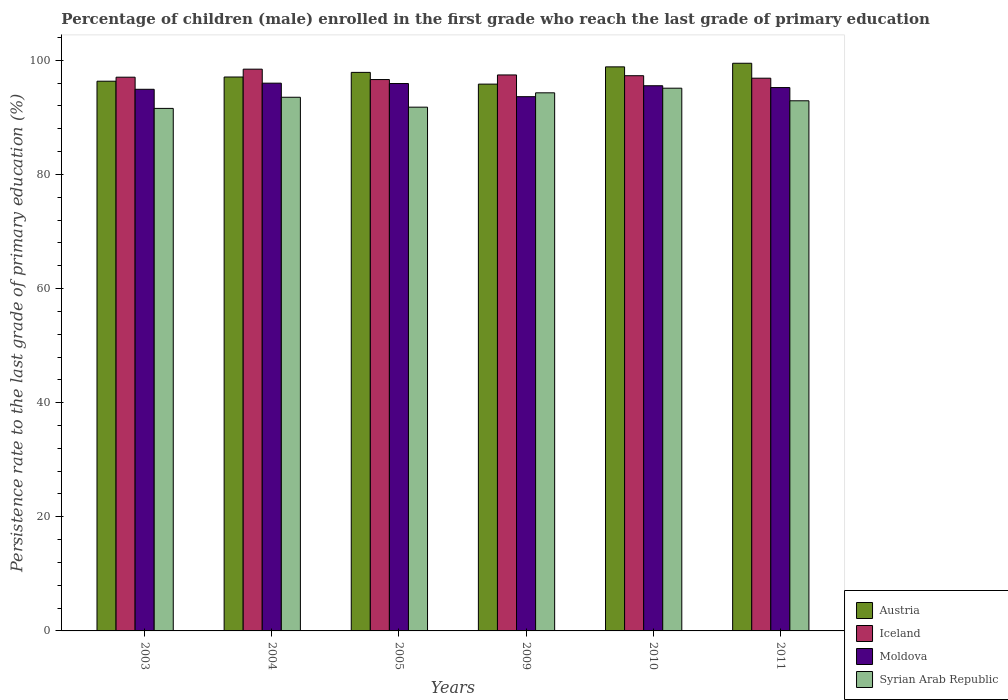How many bars are there on the 4th tick from the left?
Your answer should be compact. 4. How many bars are there on the 6th tick from the right?
Your answer should be compact. 4. In how many cases, is the number of bars for a given year not equal to the number of legend labels?
Provide a short and direct response. 0. What is the persistence rate of children in Iceland in 2010?
Offer a very short reply. 97.31. Across all years, what is the maximum persistence rate of children in Iceland?
Offer a terse response. 98.46. Across all years, what is the minimum persistence rate of children in Iceland?
Your response must be concise. 96.63. In which year was the persistence rate of children in Austria maximum?
Provide a succinct answer. 2011. What is the total persistence rate of children in Iceland in the graph?
Your answer should be very brief. 583.76. What is the difference between the persistence rate of children in Iceland in 2005 and that in 2011?
Provide a succinct answer. -0.24. What is the difference between the persistence rate of children in Moldova in 2011 and the persistence rate of children in Syrian Arab Republic in 2005?
Ensure brevity in your answer.  3.43. What is the average persistence rate of children in Austria per year?
Your answer should be very brief. 97.58. In the year 2003, what is the difference between the persistence rate of children in Moldova and persistence rate of children in Iceland?
Your answer should be very brief. -2.12. What is the ratio of the persistence rate of children in Austria in 2004 to that in 2010?
Provide a short and direct response. 0.98. What is the difference between the highest and the second highest persistence rate of children in Austria?
Offer a terse response. 0.63. What is the difference between the highest and the lowest persistence rate of children in Syrian Arab Republic?
Make the answer very short. 3.54. Is the sum of the persistence rate of children in Syrian Arab Republic in 2010 and 2011 greater than the maximum persistence rate of children in Moldova across all years?
Your answer should be compact. Yes. Is it the case that in every year, the sum of the persistence rate of children in Austria and persistence rate of children in Iceland is greater than the sum of persistence rate of children in Syrian Arab Republic and persistence rate of children in Moldova?
Make the answer very short. No. How many bars are there?
Provide a short and direct response. 24. How many years are there in the graph?
Offer a very short reply. 6. What is the difference between two consecutive major ticks on the Y-axis?
Your response must be concise. 20. How are the legend labels stacked?
Make the answer very short. Vertical. What is the title of the graph?
Your response must be concise. Percentage of children (male) enrolled in the first grade who reach the last grade of primary education. Does "South Africa" appear as one of the legend labels in the graph?
Ensure brevity in your answer.  No. What is the label or title of the X-axis?
Your answer should be very brief. Years. What is the label or title of the Y-axis?
Give a very brief answer. Persistence rate to the last grade of primary education (%). What is the Persistence rate to the last grade of primary education (%) of Austria in 2003?
Offer a very short reply. 96.34. What is the Persistence rate to the last grade of primary education (%) in Iceland in 2003?
Give a very brief answer. 97.05. What is the Persistence rate to the last grade of primary education (%) in Moldova in 2003?
Your answer should be very brief. 94.93. What is the Persistence rate to the last grade of primary education (%) in Syrian Arab Republic in 2003?
Your answer should be compact. 91.58. What is the Persistence rate to the last grade of primary education (%) in Austria in 2004?
Your answer should be compact. 97.08. What is the Persistence rate to the last grade of primary education (%) of Iceland in 2004?
Your response must be concise. 98.46. What is the Persistence rate to the last grade of primary education (%) of Moldova in 2004?
Give a very brief answer. 96. What is the Persistence rate to the last grade of primary education (%) in Syrian Arab Republic in 2004?
Ensure brevity in your answer.  93.53. What is the Persistence rate to the last grade of primary education (%) in Austria in 2005?
Ensure brevity in your answer.  97.89. What is the Persistence rate to the last grade of primary education (%) in Iceland in 2005?
Make the answer very short. 96.63. What is the Persistence rate to the last grade of primary education (%) of Moldova in 2005?
Give a very brief answer. 95.93. What is the Persistence rate to the last grade of primary education (%) of Syrian Arab Republic in 2005?
Keep it short and to the point. 91.8. What is the Persistence rate to the last grade of primary education (%) of Austria in 2009?
Offer a very short reply. 95.84. What is the Persistence rate to the last grade of primary education (%) in Iceland in 2009?
Give a very brief answer. 97.44. What is the Persistence rate to the last grade of primary education (%) in Moldova in 2009?
Make the answer very short. 93.63. What is the Persistence rate to the last grade of primary education (%) in Syrian Arab Republic in 2009?
Ensure brevity in your answer.  94.31. What is the Persistence rate to the last grade of primary education (%) in Austria in 2010?
Provide a succinct answer. 98.86. What is the Persistence rate to the last grade of primary education (%) in Iceland in 2010?
Make the answer very short. 97.31. What is the Persistence rate to the last grade of primary education (%) of Moldova in 2010?
Your answer should be compact. 95.55. What is the Persistence rate to the last grade of primary education (%) of Syrian Arab Republic in 2010?
Ensure brevity in your answer.  95.12. What is the Persistence rate to the last grade of primary education (%) in Austria in 2011?
Offer a very short reply. 99.49. What is the Persistence rate to the last grade of primary education (%) in Iceland in 2011?
Your answer should be very brief. 96.87. What is the Persistence rate to the last grade of primary education (%) of Moldova in 2011?
Give a very brief answer. 95.23. What is the Persistence rate to the last grade of primary education (%) of Syrian Arab Republic in 2011?
Offer a terse response. 92.91. Across all years, what is the maximum Persistence rate to the last grade of primary education (%) of Austria?
Give a very brief answer. 99.49. Across all years, what is the maximum Persistence rate to the last grade of primary education (%) of Iceland?
Your answer should be compact. 98.46. Across all years, what is the maximum Persistence rate to the last grade of primary education (%) of Moldova?
Offer a very short reply. 96. Across all years, what is the maximum Persistence rate to the last grade of primary education (%) in Syrian Arab Republic?
Your answer should be very brief. 95.12. Across all years, what is the minimum Persistence rate to the last grade of primary education (%) of Austria?
Make the answer very short. 95.84. Across all years, what is the minimum Persistence rate to the last grade of primary education (%) of Iceland?
Provide a short and direct response. 96.63. Across all years, what is the minimum Persistence rate to the last grade of primary education (%) in Moldova?
Ensure brevity in your answer.  93.63. Across all years, what is the minimum Persistence rate to the last grade of primary education (%) of Syrian Arab Republic?
Provide a short and direct response. 91.58. What is the total Persistence rate to the last grade of primary education (%) of Austria in the graph?
Your answer should be compact. 585.5. What is the total Persistence rate to the last grade of primary education (%) in Iceland in the graph?
Provide a succinct answer. 583.76. What is the total Persistence rate to the last grade of primary education (%) in Moldova in the graph?
Your response must be concise. 571.28. What is the total Persistence rate to the last grade of primary education (%) in Syrian Arab Republic in the graph?
Offer a terse response. 559.24. What is the difference between the Persistence rate to the last grade of primary education (%) of Austria in 2003 and that in 2004?
Provide a short and direct response. -0.74. What is the difference between the Persistence rate to the last grade of primary education (%) in Iceland in 2003 and that in 2004?
Offer a very short reply. -1.41. What is the difference between the Persistence rate to the last grade of primary education (%) in Moldova in 2003 and that in 2004?
Keep it short and to the point. -1.07. What is the difference between the Persistence rate to the last grade of primary education (%) of Syrian Arab Republic in 2003 and that in 2004?
Offer a very short reply. -1.95. What is the difference between the Persistence rate to the last grade of primary education (%) in Austria in 2003 and that in 2005?
Your answer should be compact. -1.55. What is the difference between the Persistence rate to the last grade of primary education (%) in Iceland in 2003 and that in 2005?
Keep it short and to the point. 0.41. What is the difference between the Persistence rate to the last grade of primary education (%) of Moldova in 2003 and that in 2005?
Offer a terse response. -1.01. What is the difference between the Persistence rate to the last grade of primary education (%) in Syrian Arab Republic in 2003 and that in 2005?
Your answer should be very brief. -0.22. What is the difference between the Persistence rate to the last grade of primary education (%) in Austria in 2003 and that in 2009?
Your answer should be very brief. 0.51. What is the difference between the Persistence rate to the last grade of primary education (%) of Iceland in 2003 and that in 2009?
Your response must be concise. -0.4. What is the difference between the Persistence rate to the last grade of primary education (%) of Moldova in 2003 and that in 2009?
Offer a terse response. 1.3. What is the difference between the Persistence rate to the last grade of primary education (%) in Syrian Arab Republic in 2003 and that in 2009?
Your response must be concise. -2.73. What is the difference between the Persistence rate to the last grade of primary education (%) of Austria in 2003 and that in 2010?
Your answer should be compact. -2.52. What is the difference between the Persistence rate to the last grade of primary education (%) in Iceland in 2003 and that in 2010?
Give a very brief answer. -0.26. What is the difference between the Persistence rate to the last grade of primary education (%) in Moldova in 2003 and that in 2010?
Offer a terse response. -0.62. What is the difference between the Persistence rate to the last grade of primary education (%) in Syrian Arab Republic in 2003 and that in 2010?
Keep it short and to the point. -3.54. What is the difference between the Persistence rate to the last grade of primary education (%) of Austria in 2003 and that in 2011?
Give a very brief answer. -3.15. What is the difference between the Persistence rate to the last grade of primary education (%) in Iceland in 2003 and that in 2011?
Provide a succinct answer. 0.17. What is the difference between the Persistence rate to the last grade of primary education (%) in Moldova in 2003 and that in 2011?
Give a very brief answer. -0.3. What is the difference between the Persistence rate to the last grade of primary education (%) in Syrian Arab Republic in 2003 and that in 2011?
Offer a terse response. -1.33. What is the difference between the Persistence rate to the last grade of primary education (%) in Austria in 2004 and that in 2005?
Ensure brevity in your answer.  -0.81. What is the difference between the Persistence rate to the last grade of primary education (%) of Iceland in 2004 and that in 2005?
Offer a terse response. 1.82. What is the difference between the Persistence rate to the last grade of primary education (%) in Moldova in 2004 and that in 2005?
Your response must be concise. 0.07. What is the difference between the Persistence rate to the last grade of primary education (%) in Syrian Arab Republic in 2004 and that in 2005?
Your answer should be compact. 1.74. What is the difference between the Persistence rate to the last grade of primary education (%) of Austria in 2004 and that in 2009?
Offer a terse response. 1.24. What is the difference between the Persistence rate to the last grade of primary education (%) in Iceland in 2004 and that in 2009?
Provide a short and direct response. 1.01. What is the difference between the Persistence rate to the last grade of primary education (%) of Moldova in 2004 and that in 2009?
Your answer should be compact. 2.37. What is the difference between the Persistence rate to the last grade of primary education (%) in Syrian Arab Republic in 2004 and that in 2009?
Your response must be concise. -0.78. What is the difference between the Persistence rate to the last grade of primary education (%) in Austria in 2004 and that in 2010?
Give a very brief answer. -1.78. What is the difference between the Persistence rate to the last grade of primary education (%) of Iceland in 2004 and that in 2010?
Keep it short and to the point. 1.15. What is the difference between the Persistence rate to the last grade of primary education (%) of Moldova in 2004 and that in 2010?
Your answer should be very brief. 0.45. What is the difference between the Persistence rate to the last grade of primary education (%) in Syrian Arab Republic in 2004 and that in 2010?
Offer a terse response. -1.59. What is the difference between the Persistence rate to the last grade of primary education (%) of Austria in 2004 and that in 2011?
Ensure brevity in your answer.  -2.41. What is the difference between the Persistence rate to the last grade of primary education (%) in Iceland in 2004 and that in 2011?
Provide a short and direct response. 1.58. What is the difference between the Persistence rate to the last grade of primary education (%) of Moldova in 2004 and that in 2011?
Your answer should be compact. 0.77. What is the difference between the Persistence rate to the last grade of primary education (%) in Syrian Arab Republic in 2004 and that in 2011?
Keep it short and to the point. 0.62. What is the difference between the Persistence rate to the last grade of primary education (%) in Austria in 2005 and that in 2009?
Ensure brevity in your answer.  2.06. What is the difference between the Persistence rate to the last grade of primary education (%) in Iceland in 2005 and that in 2009?
Your answer should be compact. -0.81. What is the difference between the Persistence rate to the last grade of primary education (%) of Moldova in 2005 and that in 2009?
Provide a short and direct response. 2.3. What is the difference between the Persistence rate to the last grade of primary education (%) in Syrian Arab Republic in 2005 and that in 2009?
Give a very brief answer. -2.51. What is the difference between the Persistence rate to the last grade of primary education (%) of Austria in 2005 and that in 2010?
Your response must be concise. -0.97. What is the difference between the Persistence rate to the last grade of primary education (%) of Iceland in 2005 and that in 2010?
Ensure brevity in your answer.  -0.67. What is the difference between the Persistence rate to the last grade of primary education (%) of Moldova in 2005 and that in 2010?
Your answer should be compact. 0.38. What is the difference between the Persistence rate to the last grade of primary education (%) of Syrian Arab Republic in 2005 and that in 2010?
Your answer should be compact. -3.32. What is the difference between the Persistence rate to the last grade of primary education (%) of Austria in 2005 and that in 2011?
Offer a terse response. -1.6. What is the difference between the Persistence rate to the last grade of primary education (%) of Iceland in 2005 and that in 2011?
Your answer should be compact. -0.24. What is the difference between the Persistence rate to the last grade of primary education (%) of Moldova in 2005 and that in 2011?
Offer a terse response. 0.71. What is the difference between the Persistence rate to the last grade of primary education (%) of Syrian Arab Republic in 2005 and that in 2011?
Offer a very short reply. -1.12. What is the difference between the Persistence rate to the last grade of primary education (%) in Austria in 2009 and that in 2010?
Offer a terse response. -3.02. What is the difference between the Persistence rate to the last grade of primary education (%) of Iceland in 2009 and that in 2010?
Give a very brief answer. 0.13. What is the difference between the Persistence rate to the last grade of primary education (%) of Moldova in 2009 and that in 2010?
Keep it short and to the point. -1.92. What is the difference between the Persistence rate to the last grade of primary education (%) in Syrian Arab Republic in 2009 and that in 2010?
Ensure brevity in your answer.  -0.81. What is the difference between the Persistence rate to the last grade of primary education (%) of Austria in 2009 and that in 2011?
Make the answer very short. -3.65. What is the difference between the Persistence rate to the last grade of primary education (%) of Iceland in 2009 and that in 2011?
Offer a terse response. 0.57. What is the difference between the Persistence rate to the last grade of primary education (%) in Moldova in 2009 and that in 2011?
Offer a terse response. -1.6. What is the difference between the Persistence rate to the last grade of primary education (%) in Syrian Arab Republic in 2009 and that in 2011?
Your answer should be compact. 1.4. What is the difference between the Persistence rate to the last grade of primary education (%) of Austria in 2010 and that in 2011?
Provide a succinct answer. -0.63. What is the difference between the Persistence rate to the last grade of primary education (%) of Iceland in 2010 and that in 2011?
Your answer should be compact. 0.43. What is the difference between the Persistence rate to the last grade of primary education (%) of Moldova in 2010 and that in 2011?
Keep it short and to the point. 0.32. What is the difference between the Persistence rate to the last grade of primary education (%) in Syrian Arab Republic in 2010 and that in 2011?
Offer a very short reply. 2.21. What is the difference between the Persistence rate to the last grade of primary education (%) of Austria in 2003 and the Persistence rate to the last grade of primary education (%) of Iceland in 2004?
Provide a short and direct response. -2.11. What is the difference between the Persistence rate to the last grade of primary education (%) in Austria in 2003 and the Persistence rate to the last grade of primary education (%) in Moldova in 2004?
Give a very brief answer. 0.34. What is the difference between the Persistence rate to the last grade of primary education (%) in Austria in 2003 and the Persistence rate to the last grade of primary education (%) in Syrian Arab Republic in 2004?
Your response must be concise. 2.81. What is the difference between the Persistence rate to the last grade of primary education (%) in Iceland in 2003 and the Persistence rate to the last grade of primary education (%) in Moldova in 2004?
Offer a very short reply. 1.04. What is the difference between the Persistence rate to the last grade of primary education (%) in Iceland in 2003 and the Persistence rate to the last grade of primary education (%) in Syrian Arab Republic in 2004?
Your answer should be compact. 3.52. What is the difference between the Persistence rate to the last grade of primary education (%) of Moldova in 2003 and the Persistence rate to the last grade of primary education (%) of Syrian Arab Republic in 2004?
Make the answer very short. 1.4. What is the difference between the Persistence rate to the last grade of primary education (%) of Austria in 2003 and the Persistence rate to the last grade of primary education (%) of Iceland in 2005?
Ensure brevity in your answer.  -0.29. What is the difference between the Persistence rate to the last grade of primary education (%) of Austria in 2003 and the Persistence rate to the last grade of primary education (%) of Moldova in 2005?
Your answer should be very brief. 0.41. What is the difference between the Persistence rate to the last grade of primary education (%) in Austria in 2003 and the Persistence rate to the last grade of primary education (%) in Syrian Arab Republic in 2005?
Ensure brevity in your answer.  4.55. What is the difference between the Persistence rate to the last grade of primary education (%) in Iceland in 2003 and the Persistence rate to the last grade of primary education (%) in Moldova in 2005?
Offer a terse response. 1.11. What is the difference between the Persistence rate to the last grade of primary education (%) in Iceland in 2003 and the Persistence rate to the last grade of primary education (%) in Syrian Arab Republic in 2005?
Offer a very short reply. 5.25. What is the difference between the Persistence rate to the last grade of primary education (%) of Moldova in 2003 and the Persistence rate to the last grade of primary education (%) of Syrian Arab Republic in 2005?
Provide a short and direct response. 3.13. What is the difference between the Persistence rate to the last grade of primary education (%) in Austria in 2003 and the Persistence rate to the last grade of primary education (%) in Iceland in 2009?
Your answer should be compact. -1.1. What is the difference between the Persistence rate to the last grade of primary education (%) in Austria in 2003 and the Persistence rate to the last grade of primary education (%) in Moldova in 2009?
Provide a succinct answer. 2.71. What is the difference between the Persistence rate to the last grade of primary education (%) in Austria in 2003 and the Persistence rate to the last grade of primary education (%) in Syrian Arab Republic in 2009?
Offer a terse response. 2.03. What is the difference between the Persistence rate to the last grade of primary education (%) of Iceland in 2003 and the Persistence rate to the last grade of primary education (%) of Moldova in 2009?
Make the answer very short. 3.41. What is the difference between the Persistence rate to the last grade of primary education (%) of Iceland in 2003 and the Persistence rate to the last grade of primary education (%) of Syrian Arab Republic in 2009?
Your response must be concise. 2.74. What is the difference between the Persistence rate to the last grade of primary education (%) in Moldova in 2003 and the Persistence rate to the last grade of primary education (%) in Syrian Arab Republic in 2009?
Your response must be concise. 0.62. What is the difference between the Persistence rate to the last grade of primary education (%) in Austria in 2003 and the Persistence rate to the last grade of primary education (%) in Iceland in 2010?
Ensure brevity in your answer.  -0.97. What is the difference between the Persistence rate to the last grade of primary education (%) of Austria in 2003 and the Persistence rate to the last grade of primary education (%) of Moldova in 2010?
Give a very brief answer. 0.79. What is the difference between the Persistence rate to the last grade of primary education (%) of Austria in 2003 and the Persistence rate to the last grade of primary education (%) of Syrian Arab Republic in 2010?
Your answer should be compact. 1.22. What is the difference between the Persistence rate to the last grade of primary education (%) of Iceland in 2003 and the Persistence rate to the last grade of primary education (%) of Moldova in 2010?
Give a very brief answer. 1.5. What is the difference between the Persistence rate to the last grade of primary education (%) of Iceland in 2003 and the Persistence rate to the last grade of primary education (%) of Syrian Arab Republic in 2010?
Keep it short and to the point. 1.93. What is the difference between the Persistence rate to the last grade of primary education (%) of Moldova in 2003 and the Persistence rate to the last grade of primary education (%) of Syrian Arab Republic in 2010?
Your answer should be compact. -0.19. What is the difference between the Persistence rate to the last grade of primary education (%) in Austria in 2003 and the Persistence rate to the last grade of primary education (%) in Iceland in 2011?
Your answer should be very brief. -0.53. What is the difference between the Persistence rate to the last grade of primary education (%) of Austria in 2003 and the Persistence rate to the last grade of primary education (%) of Moldova in 2011?
Provide a short and direct response. 1.11. What is the difference between the Persistence rate to the last grade of primary education (%) of Austria in 2003 and the Persistence rate to the last grade of primary education (%) of Syrian Arab Republic in 2011?
Ensure brevity in your answer.  3.43. What is the difference between the Persistence rate to the last grade of primary education (%) of Iceland in 2003 and the Persistence rate to the last grade of primary education (%) of Moldova in 2011?
Ensure brevity in your answer.  1.82. What is the difference between the Persistence rate to the last grade of primary education (%) of Iceland in 2003 and the Persistence rate to the last grade of primary education (%) of Syrian Arab Republic in 2011?
Make the answer very short. 4.13. What is the difference between the Persistence rate to the last grade of primary education (%) in Moldova in 2003 and the Persistence rate to the last grade of primary education (%) in Syrian Arab Republic in 2011?
Make the answer very short. 2.02. What is the difference between the Persistence rate to the last grade of primary education (%) of Austria in 2004 and the Persistence rate to the last grade of primary education (%) of Iceland in 2005?
Offer a terse response. 0.45. What is the difference between the Persistence rate to the last grade of primary education (%) in Austria in 2004 and the Persistence rate to the last grade of primary education (%) in Moldova in 2005?
Keep it short and to the point. 1.15. What is the difference between the Persistence rate to the last grade of primary education (%) in Austria in 2004 and the Persistence rate to the last grade of primary education (%) in Syrian Arab Republic in 2005?
Your answer should be compact. 5.28. What is the difference between the Persistence rate to the last grade of primary education (%) in Iceland in 2004 and the Persistence rate to the last grade of primary education (%) in Moldova in 2005?
Ensure brevity in your answer.  2.52. What is the difference between the Persistence rate to the last grade of primary education (%) of Iceland in 2004 and the Persistence rate to the last grade of primary education (%) of Syrian Arab Republic in 2005?
Ensure brevity in your answer.  6.66. What is the difference between the Persistence rate to the last grade of primary education (%) of Moldova in 2004 and the Persistence rate to the last grade of primary education (%) of Syrian Arab Republic in 2005?
Your answer should be very brief. 4.21. What is the difference between the Persistence rate to the last grade of primary education (%) in Austria in 2004 and the Persistence rate to the last grade of primary education (%) in Iceland in 2009?
Your answer should be compact. -0.36. What is the difference between the Persistence rate to the last grade of primary education (%) of Austria in 2004 and the Persistence rate to the last grade of primary education (%) of Moldova in 2009?
Ensure brevity in your answer.  3.45. What is the difference between the Persistence rate to the last grade of primary education (%) in Austria in 2004 and the Persistence rate to the last grade of primary education (%) in Syrian Arab Republic in 2009?
Your response must be concise. 2.77. What is the difference between the Persistence rate to the last grade of primary education (%) in Iceland in 2004 and the Persistence rate to the last grade of primary education (%) in Moldova in 2009?
Give a very brief answer. 4.82. What is the difference between the Persistence rate to the last grade of primary education (%) of Iceland in 2004 and the Persistence rate to the last grade of primary education (%) of Syrian Arab Republic in 2009?
Offer a terse response. 4.15. What is the difference between the Persistence rate to the last grade of primary education (%) in Moldova in 2004 and the Persistence rate to the last grade of primary education (%) in Syrian Arab Republic in 2009?
Your answer should be compact. 1.69. What is the difference between the Persistence rate to the last grade of primary education (%) in Austria in 2004 and the Persistence rate to the last grade of primary education (%) in Iceland in 2010?
Your answer should be compact. -0.23. What is the difference between the Persistence rate to the last grade of primary education (%) of Austria in 2004 and the Persistence rate to the last grade of primary education (%) of Moldova in 2010?
Make the answer very short. 1.53. What is the difference between the Persistence rate to the last grade of primary education (%) in Austria in 2004 and the Persistence rate to the last grade of primary education (%) in Syrian Arab Republic in 2010?
Keep it short and to the point. 1.96. What is the difference between the Persistence rate to the last grade of primary education (%) in Iceland in 2004 and the Persistence rate to the last grade of primary education (%) in Moldova in 2010?
Make the answer very short. 2.91. What is the difference between the Persistence rate to the last grade of primary education (%) of Iceland in 2004 and the Persistence rate to the last grade of primary education (%) of Syrian Arab Republic in 2010?
Your answer should be compact. 3.34. What is the difference between the Persistence rate to the last grade of primary education (%) of Moldova in 2004 and the Persistence rate to the last grade of primary education (%) of Syrian Arab Republic in 2010?
Provide a succinct answer. 0.88. What is the difference between the Persistence rate to the last grade of primary education (%) in Austria in 2004 and the Persistence rate to the last grade of primary education (%) in Iceland in 2011?
Ensure brevity in your answer.  0.21. What is the difference between the Persistence rate to the last grade of primary education (%) in Austria in 2004 and the Persistence rate to the last grade of primary education (%) in Moldova in 2011?
Your response must be concise. 1.85. What is the difference between the Persistence rate to the last grade of primary education (%) in Austria in 2004 and the Persistence rate to the last grade of primary education (%) in Syrian Arab Republic in 2011?
Provide a succinct answer. 4.17. What is the difference between the Persistence rate to the last grade of primary education (%) of Iceland in 2004 and the Persistence rate to the last grade of primary education (%) of Moldova in 2011?
Keep it short and to the point. 3.23. What is the difference between the Persistence rate to the last grade of primary education (%) in Iceland in 2004 and the Persistence rate to the last grade of primary education (%) in Syrian Arab Republic in 2011?
Offer a very short reply. 5.54. What is the difference between the Persistence rate to the last grade of primary education (%) of Moldova in 2004 and the Persistence rate to the last grade of primary education (%) of Syrian Arab Republic in 2011?
Keep it short and to the point. 3.09. What is the difference between the Persistence rate to the last grade of primary education (%) of Austria in 2005 and the Persistence rate to the last grade of primary education (%) of Iceland in 2009?
Give a very brief answer. 0.45. What is the difference between the Persistence rate to the last grade of primary education (%) in Austria in 2005 and the Persistence rate to the last grade of primary education (%) in Moldova in 2009?
Offer a very short reply. 4.26. What is the difference between the Persistence rate to the last grade of primary education (%) in Austria in 2005 and the Persistence rate to the last grade of primary education (%) in Syrian Arab Republic in 2009?
Offer a very short reply. 3.58. What is the difference between the Persistence rate to the last grade of primary education (%) of Iceland in 2005 and the Persistence rate to the last grade of primary education (%) of Moldova in 2009?
Offer a terse response. 3. What is the difference between the Persistence rate to the last grade of primary education (%) in Iceland in 2005 and the Persistence rate to the last grade of primary education (%) in Syrian Arab Republic in 2009?
Provide a short and direct response. 2.33. What is the difference between the Persistence rate to the last grade of primary education (%) in Moldova in 2005 and the Persistence rate to the last grade of primary education (%) in Syrian Arab Republic in 2009?
Keep it short and to the point. 1.63. What is the difference between the Persistence rate to the last grade of primary education (%) in Austria in 2005 and the Persistence rate to the last grade of primary education (%) in Iceland in 2010?
Your answer should be compact. 0.58. What is the difference between the Persistence rate to the last grade of primary education (%) in Austria in 2005 and the Persistence rate to the last grade of primary education (%) in Moldova in 2010?
Provide a succinct answer. 2.34. What is the difference between the Persistence rate to the last grade of primary education (%) of Austria in 2005 and the Persistence rate to the last grade of primary education (%) of Syrian Arab Republic in 2010?
Make the answer very short. 2.77. What is the difference between the Persistence rate to the last grade of primary education (%) of Iceland in 2005 and the Persistence rate to the last grade of primary education (%) of Moldova in 2010?
Keep it short and to the point. 1.08. What is the difference between the Persistence rate to the last grade of primary education (%) of Iceland in 2005 and the Persistence rate to the last grade of primary education (%) of Syrian Arab Republic in 2010?
Make the answer very short. 1.52. What is the difference between the Persistence rate to the last grade of primary education (%) of Moldova in 2005 and the Persistence rate to the last grade of primary education (%) of Syrian Arab Republic in 2010?
Your answer should be very brief. 0.82. What is the difference between the Persistence rate to the last grade of primary education (%) in Austria in 2005 and the Persistence rate to the last grade of primary education (%) in Iceland in 2011?
Keep it short and to the point. 1.02. What is the difference between the Persistence rate to the last grade of primary education (%) of Austria in 2005 and the Persistence rate to the last grade of primary education (%) of Moldova in 2011?
Provide a short and direct response. 2.66. What is the difference between the Persistence rate to the last grade of primary education (%) of Austria in 2005 and the Persistence rate to the last grade of primary education (%) of Syrian Arab Republic in 2011?
Provide a succinct answer. 4.98. What is the difference between the Persistence rate to the last grade of primary education (%) in Iceland in 2005 and the Persistence rate to the last grade of primary education (%) in Moldova in 2011?
Give a very brief answer. 1.41. What is the difference between the Persistence rate to the last grade of primary education (%) in Iceland in 2005 and the Persistence rate to the last grade of primary education (%) in Syrian Arab Republic in 2011?
Ensure brevity in your answer.  3.72. What is the difference between the Persistence rate to the last grade of primary education (%) in Moldova in 2005 and the Persistence rate to the last grade of primary education (%) in Syrian Arab Republic in 2011?
Keep it short and to the point. 3.02. What is the difference between the Persistence rate to the last grade of primary education (%) of Austria in 2009 and the Persistence rate to the last grade of primary education (%) of Iceland in 2010?
Ensure brevity in your answer.  -1.47. What is the difference between the Persistence rate to the last grade of primary education (%) of Austria in 2009 and the Persistence rate to the last grade of primary education (%) of Moldova in 2010?
Provide a short and direct response. 0.28. What is the difference between the Persistence rate to the last grade of primary education (%) of Austria in 2009 and the Persistence rate to the last grade of primary education (%) of Syrian Arab Republic in 2010?
Offer a terse response. 0.72. What is the difference between the Persistence rate to the last grade of primary education (%) in Iceland in 2009 and the Persistence rate to the last grade of primary education (%) in Moldova in 2010?
Your response must be concise. 1.89. What is the difference between the Persistence rate to the last grade of primary education (%) of Iceland in 2009 and the Persistence rate to the last grade of primary education (%) of Syrian Arab Republic in 2010?
Ensure brevity in your answer.  2.32. What is the difference between the Persistence rate to the last grade of primary education (%) in Moldova in 2009 and the Persistence rate to the last grade of primary education (%) in Syrian Arab Republic in 2010?
Ensure brevity in your answer.  -1.49. What is the difference between the Persistence rate to the last grade of primary education (%) of Austria in 2009 and the Persistence rate to the last grade of primary education (%) of Iceland in 2011?
Make the answer very short. -1.04. What is the difference between the Persistence rate to the last grade of primary education (%) in Austria in 2009 and the Persistence rate to the last grade of primary education (%) in Moldova in 2011?
Offer a terse response. 0.61. What is the difference between the Persistence rate to the last grade of primary education (%) of Austria in 2009 and the Persistence rate to the last grade of primary education (%) of Syrian Arab Republic in 2011?
Offer a very short reply. 2.92. What is the difference between the Persistence rate to the last grade of primary education (%) of Iceland in 2009 and the Persistence rate to the last grade of primary education (%) of Moldova in 2011?
Offer a terse response. 2.21. What is the difference between the Persistence rate to the last grade of primary education (%) of Iceland in 2009 and the Persistence rate to the last grade of primary education (%) of Syrian Arab Republic in 2011?
Give a very brief answer. 4.53. What is the difference between the Persistence rate to the last grade of primary education (%) of Moldova in 2009 and the Persistence rate to the last grade of primary education (%) of Syrian Arab Republic in 2011?
Your answer should be very brief. 0.72. What is the difference between the Persistence rate to the last grade of primary education (%) of Austria in 2010 and the Persistence rate to the last grade of primary education (%) of Iceland in 2011?
Your response must be concise. 1.99. What is the difference between the Persistence rate to the last grade of primary education (%) in Austria in 2010 and the Persistence rate to the last grade of primary education (%) in Moldova in 2011?
Make the answer very short. 3.63. What is the difference between the Persistence rate to the last grade of primary education (%) of Austria in 2010 and the Persistence rate to the last grade of primary education (%) of Syrian Arab Republic in 2011?
Your response must be concise. 5.95. What is the difference between the Persistence rate to the last grade of primary education (%) of Iceland in 2010 and the Persistence rate to the last grade of primary education (%) of Moldova in 2011?
Give a very brief answer. 2.08. What is the difference between the Persistence rate to the last grade of primary education (%) in Iceland in 2010 and the Persistence rate to the last grade of primary education (%) in Syrian Arab Republic in 2011?
Your answer should be compact. 4.4. What is the difference between the Persistence rate to the last grade of primary education (%) in Moldova in 2010 and the Persistence rate to the last grade of primary education (%) in Syrian Arab Republic in 2011?
Your response must be concise. 2.64. What is the average Persistence rate to the last grade of primary education (%) in Austria per year?
Keep it short and to the point. 97.58. What is the average Persistence rate to the last grade of primary education (%) in Iceland per year?
Ensure brevity in your answer.  97.29. What is the average Persistence rate to the last grade of primary education (%) of Moldova per year?
Your answer should be very brief. 95.21. What is the average Persistence rate to the last grade of primary education (%) in Syrian Arab Republic per year?
Your answer should be compact. 93.21. In the year 2003, what is the difference between the Persistence rate to the last grade of primary education (%) in Austria and Persistence rate to the last grade of primary education (%) in Iceland?
Offer a very short reply. -0.7. In the year 2003, what is the difference between the Persistence rate to the last grade of primary education (%) of Austria and Persistence rate to the last grade of primary education (%) of Moldova?
Give a very brief answer. 1.42. In the year 2003, what is the difference between the Persistence rate to the last grade of primary education (%) in Austria and Persistence rate to the last grade of primary education (%) in Syrian Arab Republic?
Provide a succinct answer. 4.76. In the year 2003, what is the difference between the Persistence rate to the last grade of primary education (%) in Iceland and Persistence rate to the last grade of primary education (%) in Moldova?
Give a very brief answer. 2.12. In the year 2003, what is the difference between the Persistence rate to the last grade of primary education (%) of Iceland and Persistence rate to the last grade of primary education (%) of Syrian Arab Republic?
Offer a terse response. 5.47. In the year 2003, what is the difference between the Persistence rate to the last grade of primary education (%) of Moldova and Persistence rate to the last grade of primary education (%) of Syrian Arab Republic?
Offer a terse response. 3.35. In the year 2004, what is the difference between the Persistence rate to the last grade of primary education (%) of Austria and Persistence rate to the last grade of primary education (%) of Iceland?
Give a very brief answer. -1.38. In the year 2004, what is the difference between the Persistence rate to the last grade of primary education (%) in Austria and Persistence rate to the last grade of primary education (%) in Moldova?
Offer a terse response. 1.08. In the year 2004, what is the difference between the Persistence rate to the last grade of primary education (%) in Austria and Persistence rate to the last grade of primary education (%) in Syrian Arab Republic?
Make the answer very short. 3.55. In the year 2004, what is the difference between the Persistence rate to the last grade of primary education (%) of Iceland and Persistence rate to the last grade of primary education (%) of Moldova?
Give a very brief answer. 2.45. In the year 2004, what is the difference between the Persistence rate to the last grade of primary education (%) in Iceland and Persistence rate to the last grade of primary education (%) in Syrian Arab Republic?
Ensure brevity in your answer.  4.93. In the year 2004, what is the difference between the Persistence rate to the last grade of primary education (%) in Moldova and Persistence rate to the last grade of primary education (%) in Syrian Arab Republic?
Ensure brevity in your answer.  2.47. In the year 2005, what is the difference between the Persistence rate to the last grade of primary education (%) of Austria and Persistence rate to the last grade of primary education (%) of Iceland?
Your response must be concise. 1.26. In the year 2005, what is the difference between the Persistence rate to the last grade of primary education (%) of Austria and Persistence rate to the last grade of primary education (%) of Moldova?
Provide a short and direct response. 1.96. In the year 2005, what is the difference between the Persistence rate to the last grade of primary education (%) of Austria and Persistence rate to the last grade of primary education (%) of Syrian Arab Republic?
Make the answer very short. 6.1. In the year 2005, what is the difference between the Persistence rate to the last grade of primary education (%) of Iceland and Persistence rate to the last grade of primary education (%) of Moldova?
Your response must be concise. 0.7. In the year 2005, what is the difference between the Persistence rate to the last grade of primary education (%) of Iceland and Persistence rate to the last grade of primary education (%) of Syrian Arab Republic?
Give a very brief answer. 4.84. In the year 2005, what is the difference between the Persistence rate to the last grade of primary education (%) of Moldova and Persistence rate to the last grade of primary education (%) of Syrian Arab Republic?
Offer a terse response. 4.14. In the year 2009, what is the difference between the Persistence rate to the last grade of primary education (%) of Austria and Persistence rate to the last grade of primary education (%) of Iceland?
Your answer should be compact. -1.61. In the year 2009, what is the difference between the Persistence rate to the last grade of primary education (%) in Austria and Persistence rate to the last grade of primary education (%) in Moldova?
Your response must be concise. 2.2. In the year 2009, what is the difference between the Persistence rate to the last grade of primary education (%) of Austria and Persistence rate to the last grade of primary education (%) of Syrian Arab Republic?
Give a very brief answer. 1.53. In the year 2009, what is the difference between the Persistence rate to the last grade of primary education (%) of Iceland and Persistence rate to the last grade of primary education (%) of Moldova?
Provide a short and direct response. 3.81. In the year 2009, what is the difference between the Persistence rate to the last grade of primary education (%) in Iceland and Persistence rate to the last grade of primary education (%) in Syrian Arab Republic?
Your answer should be compact. 3.13. In the year 2009, what is the difference between the Persistence rate to the last grade of primary education (%) of Moldova and Persistence rate to the last grade of primary education (%) of Syrian Arab Republic?
Keep it short and to the point. -0.68. In the year 2010, what is the difference between the Persistence rate to the last grade of primary education (%) in Austria and Persistence rate to the last grade of primary education (%) in Iceland?
Your response must be concise. 1.55. In the year 2010, what is the difference between the Persistence rate to the last grade of primary education (%) of Austria and Persistence rate to the last grade of primary education (%) of Moldova?
Your response must be concise. 3.31. In the year 2010, what is the difference between the Persistence rate to the last grade of primary education (%) of Austria and Persistence rate to the last grade of primary education (%) of Syrian Arab Republic?
Make the answer very short. 3.74. In the year 2010, what is the difference between the Persistence rate to the last grade of primary education (%) of Iceland and Persistence rate to the last grade of primary education (%) of Moldova?
Provide a succinct answer. 1.76. In the year 2010, what is the difference between the Persistence rate to the last grade of primary education (%) of Iceland and Persistence rate to the last grade of primary education (%) of Syrian Arab Republic?
Offer a terse response. 2.19. In the year 2010, what is the difference between the Persistence rate to the last grade of primary education (%) in Moldova and Persistence rate to the last grade of primary education (%) in Syrian Arab Republic?
Keep it short and to the point. 0.43. In the year 2011, what is the difference between the Persistence rate to the last grade of primary education (%) of Austria and Persistence rate to the last grade of primary education (%) of Iceland?
Your answer should be very brief. 2.62. In the year 2011, what is the difference between the Persistence rate to the last grade of primary education (%) of Austria and Persistence rate to the last grade of primary education (%) of Moldova?
Keep it short and to the point. 4.26. In the year 2011, what is the difference between the Persistence rate to the last grade of primary education (%) of Austria and Persistence rate to the last grade of primary education (%) of Syrian Arab Republic?
Ensure brevity in your answer.  6.58. In the year 2011, what is the difference between the Persistence rate to the last grade of primary education (%) of Iceland and Persistence rate to the last grade of primary education (%) of Moldova?
Ensure brevity in your answer.  1.64. In the year 2011, what is the difference between the Persistence rate to the last grade of primary education (%) in Iceland and Persistence rate to the last grade of primary education (%) in Syrian Arab Republic?
Your answer should be compact. 3.96. In the year 2011, what is the difference between the Persistence rate to the last grade of primary education (%) in Moldova and Persistence rate to the last grade of primary education (%) in Syrian Arab Republic?
Provide a short and direct response. 2.32. What is the ratio of the Persistence rate to the last grade of primary education (%) of Austria in 2003 to that in 2004?
Your response must be concise. 0.99. What is the ratio of the Persistence rate to the last grade of primary education (%) in Iceland in 2003 to that in 2004?
Offer a terse response. 0.99. What is the ratio of the Persistence rate to the last grade of primary education (%) of Syrian Arab Republic in 2003 to that in 2004?
Your answer should be compact. 0.98. What is the ratio of the Persistence rate to the last grade of primary education (%) in Austria in 2003 to that in 2005?
Offer a terse response. 0.98. What is the ratio of the Persistence rate to the last grade of primary education (%) in Moldova in 2003 to that in 2005?
Make the answer very short. 0.99. What is the ratio of the Persistence rate to the last grade of primary education (%) in Syrian Arab Republic in 2003 to that in 2005?
Ensure brevity in your answer.  1. What is the ratio of the Persistence rate to the last grade of primary education (%) in Austria in 2003 to that in 2009?
Offer a terse response. 1.01. What is the ratio of the Persistence rate to the last grade of primary education (%) of Moldova in 2003 to that in 2009?
Make the answer very short. 1.01. What is the ratio of the Persistence rate to the last grade of primary education (%) of Syrian Arab Republic in 2003 to that in 2009?
Your response must be concise. 0.97. What is the ratio of the Persistence rate to the last grade of primary education (%) in Austria in 2003 to that in 2010?
Offer a terse response. 0.97. What is the ratio of the Persistence rate to the last grade of primary education (%) in Iceland in 2003 to that in 2010?
Provide a succinct answer. 1. What is the ratio of the Persistence rate to the last grade of primary education (%) in Moldova in 2003 to that in 2010?
Make the answer very short. 0.99. What is the ratio of the Persistence rate to the last grade of primary education (%) of Syrian Arab Republic in 2003 to that in 2010?
Your response must be concise. 0.96. What is the ratio of the Persistence rate to the last grade of primary education (%) of Austria in 2003 to that in 2011?
Provide a succinct answer. 0.97. What is the ratio of the Persistence rate to the last grade of primary education (%) in Iceland in 2003 to that in 2011?
Provide a short and direct response. 1. What is the ratio of the Persistence rate to the last grade of primary education (%) of Syrian Arab Republic in 2003 to that in 2011?
Offer a terse response. 0.99. What is the ratio of the Persistence rate to the last grade of primary education (%) in Iceland in 2004 to that in 2005?
Ensure brevity in your answer.  1.02. What is the ratio of the Persistence rate to the last grade of primary education (%) in Syrian Arab Republic in 2004 to that in 2005?
Your response must be concise. 1.02. What is the ratio of the Persistence rate to the last grade of primary education (%) of Iceland in 2004 to that in 2009?
Your response must be concise. 1.01. What is the ratio of the Persistence rate to the last grade of primary education (%) of Moldova in 2004 to that in 2009?
Give a very brief answer. 1.03. What is the ratio of the Persistence rate to the last grade of primary education (%) of Iceland in 2004 to that in 2010?
Provide a succinct answer. 1.01. What is the ratio of the Persistence rate to the last grade of primary education (%) in Syrian Arab Republic in 2004 to that in 2010?
Provide a short and direct response. 0.98. What is the ratio of the Persistence rate to the last grade of primary education (%) of Austria in 2004 to that in 2011?
Offer a terse response. 0.98. What is the ratio of the Persistence rate to the last grade of primary education (%) of Iceland in 2004 to that in 2011?
Ensure brevity in your answer.  1.02. What is the ratio of the Persistence rate to the last grade of primary education (%) of Austria in 2005 to that in 2009?
Offer a very short reply. 1.02. What is the ratio of the Persistence rate to the last grade of primary education (%) in Iceland in 2005 to that in 2009?
Your answer should be compact. 0.99. What is the ratio of the Persistence rate to the last grade of primary education (%) in Moldova in 2005 to that in 2009?
Give a very brief answer. 1.02. What is the ratio of the Persistence rate to the last grade of primary education (%) in Syrian Arab Republic in 2005 to that in 2009?
Make the answer very short. 0.97. What is the ratio of the Persistence rate to the last grade of primary education (%) in Austria in 2005 to that in 2010?
Keep it short and to the point. 0.99. What is the ratio of the Persistence rate to the last grade of primary education (%) of Iceland in 2005 to that in 2010?
Your response must be concise. 0.99. What is the ratio of the Persistence rate to the last grade of primary education (%) in Moldova in 2005 to that in 2010?
Provide a succinct answer. 1. What is the ratio of the Persistence rate to the last grade of primary education (%) in Syrian Arab Republic in 2005 to that in 2010?
Keep it short and to the point. 0.97. What is the ratio of the Persistence rate to the last grade of primary education (%) of Austria in 2005 to that in 2011?
Your response must be concise. 0.98. What is the ratio of the Persistence rate to the last grade of primary education (%) of Moldova in 2005 to that in 2011?
Offer a terse response. 1.01. What is the ratio of the Persistence rate to the last grade of primary education (%) in Syrian Arab Republic in 2005 to that in 2011?
Offer a very short reply. 0.99. What is the ratio of the Persistence rate to the last grade of primary education (%) in Austria in 2009 to that in 2010?
Provide a short and direct response. 0.97. What is the ratio of the Persistence rate to the last grade of primary education (%) in Iceland in 2009 to that in 2010?
Keep it short and to the point. 1. What is the ratio of the Persistence rate to the last grade of primary education (%) of Moldova in 2009 to that in 2010?
Ensure brevity in your answer.  0.98. What is the ratio of the Persistence rate to the last grade of primary education (%) of Austria in 2009 to that in 2011?
Your response must be concise. 0.96. What is the ratio of the Persistence rate to the last grade of primary education (%) of Iceland in 2009 to that in 2011?
Your response must be concise. 1.01. What is the ratio of the Persistence rate to the last grade of primary education (%) in Moldova in 2009 to that in 2011?
Offer a very short reply. 0.98. What is the ratio of the Persistence rate to the last grade of primary education (%) in Syrian Arab Republic in 2009 to that in 2011?
Give a very brief answer. 1.01. What is the ratio of the Persistence rate to the last grade of primary education (%) in Austria in 2010 to that in 2011?
Provide a succinct answer. 0.99. What is the ratio of the Persistence rate to the last grade of primary education (%) in Syrian Arab Republic in 2010 to that in 2011?
Make the answer very short. 1.02. What is the difference between the highest and the second highest Persistence rate to the last grade of primary education (%) of Austria?
Ensure brevity in your answer.  0.63. What is the difference between the highest and the second highest Persistence rate to the last grade of primary education (%) in Iceland?
Provide a short and direct response. 1.01. What is the difference between the highest and the second highest Persistence rate to the last grade of primary education (%) of Moldova?
Provide a short and direct response. 0.07. What is the difference between the highest and the second highest Persistence rate to the last grade of primary education (%) of Syrian Arab Republic?
Offer a very short reply. 0.81. What is the difference between the highest and the lowest Persistence rate to the last grade of primary education (%) of Austria?
Provide a succinct answer. 3.65. What is the difference between the highest and the lowest Persistence rate to the last grade of primary education (%) of Iceland?
Give a very brief answer. 1.82. What is the difference between the highest and the lowest Persistence rate to the last grade of primary education (%) in Moldova?
Provide a succinct answer. 2.37. What is the difference between the highest and the lowest Persistence rate to the last grade of primary education (%) of Syrian Arab Republic?
Offer a very short reply. 3.54. 